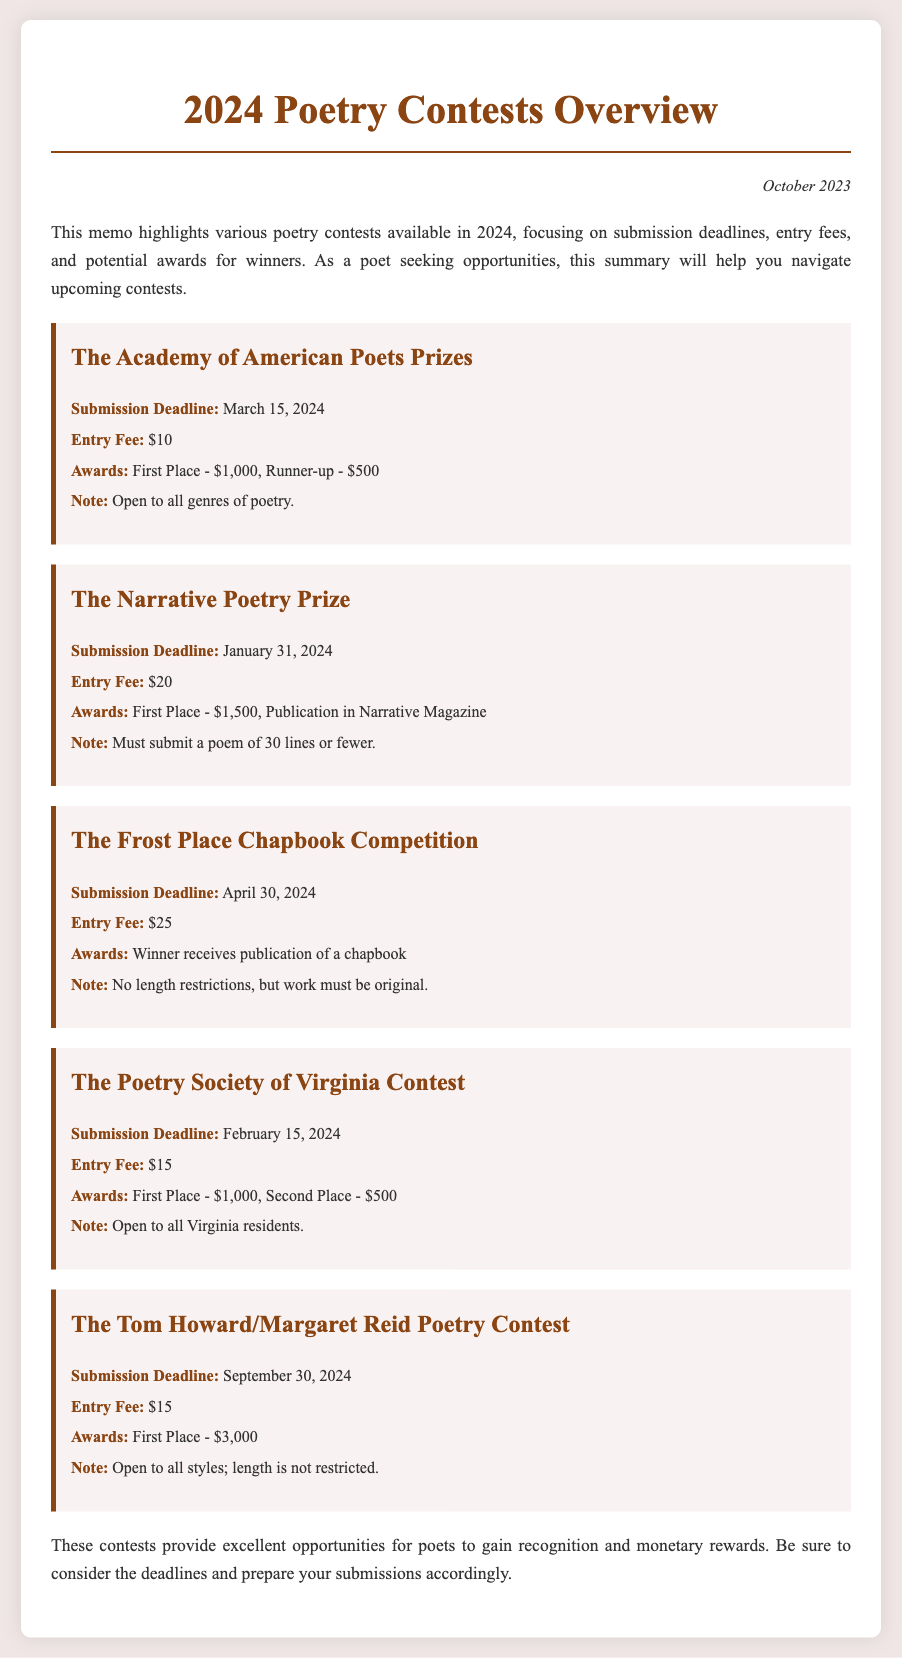what is the submission deadline for The Narrative Poetry Prize? The submission deadline is provided in the document as January 31, 2024.
Answer: January 31, 2024 what is the entry fee for The Poetry Society of Virginia Contest? The entry fee is mentioned in the document as $15.
Answer: $15 how much is the first place award for The Academy of American Poets Prizes? The document specifies the first place award is $1,000.
Answer: $1,000 which contest offers publication in Narrative Magazine as an award? The document indicates that The Narrative Poetry Prize includes publication in Narrative Magazine as an award.
Answer: The Narrative Poetry Prize what is the total prize amount for The Tom Howard/Margaret Reid Poetry Contest? The total prize amount refers to the first place award, which is $3,000 as stated in the document.
Answer: $3,000 how many contests are listed in the document? The document lists a total of five poetry contests.
Answer: Five what type of document is this memo? The nature of the document is outlined as a summary of poetry contests for 2024.
Answer: A summary of poetry contests what does the introduction highlight about the contests? The introduction emphasizes that the memo focuses on submission deadlines, entry fees, and potential awards for winners.
Answer: Submission deadlines, entry fees, and potential awards for winners who can submit to The Poetry Society of Virginia Contest? The document mentions that this contest is open to all Virginia residents.
Answer: All Virginia residents 